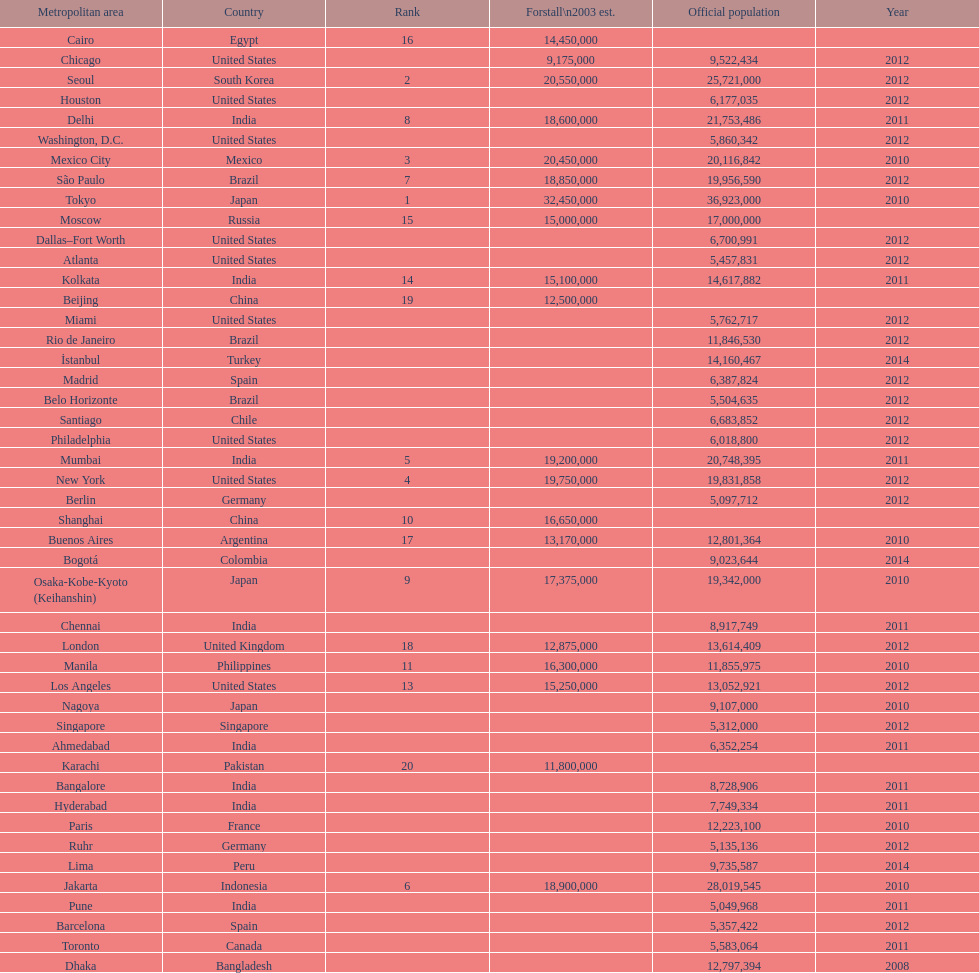Name a city from the same country as bangalore. Ahmedabad. 